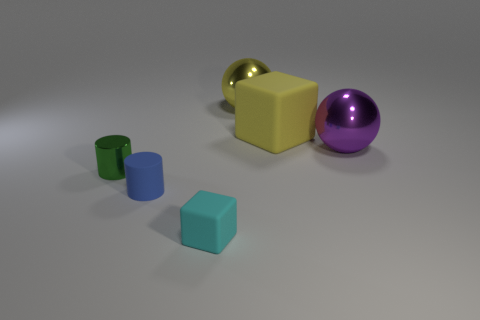Add 1 small yellow metal cubes. How many objects exist? 7 Subtract all cylinders. How many objects are left? 4 Subtract 1 cylinders. How many cylinders are left? 1 Add 1 cyan cubes. How many cyan cubes exist? 2 Subtract all cyan cubes. How many cubes are left? 1 Subtract 0 gray spheres. How many objects are left? 6 Subtract all cyan balls. Subtract all cyan cylinders. How many balls are left? 2 Subtract all red cylinders. How many purple balls are left? 1 Subtract all gray matte blocks. Subtract all small green cylinders. How many objects are left? 5 Add 2 small cubes. How many small cubes are left? 3 